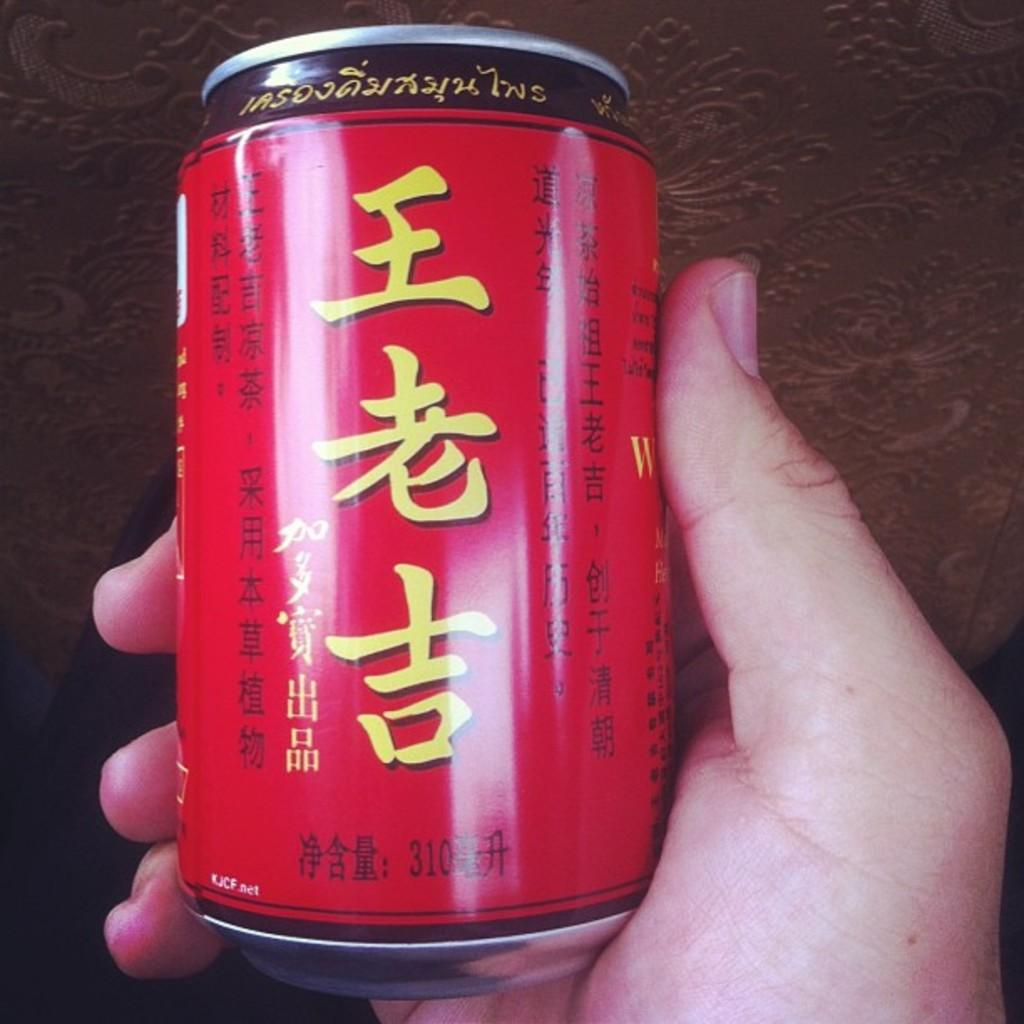<image>
Render a clear and concise summary of the photo. a red aluminum can of a drink with foreign writting on it 